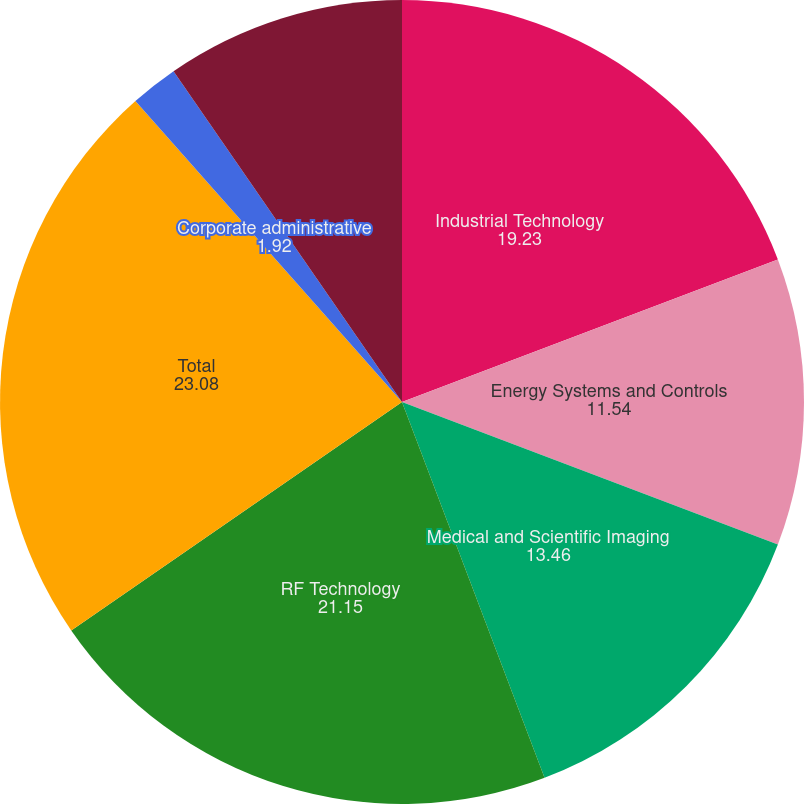Convert chart to OTSL. <chart><loc_0><loc_0><loc_500><loc_500><pie_chart><fcel>Industrial Technology<fcel>Energy Systems and Controls<fcel>Medical and Scientific Imaging<fcel>RF Technology<fcel>Total<fcel>Corporate administrative<fcel>Income from continuing<fcel>Interest expense net<nl><fcel>19.23%<fcel>11.54%<fcel>13.46%<fcel>21.15%<fcel>23.08%<fcel>1.92%<fcel>9.62%<fcel>0.0%<nl></chart> 